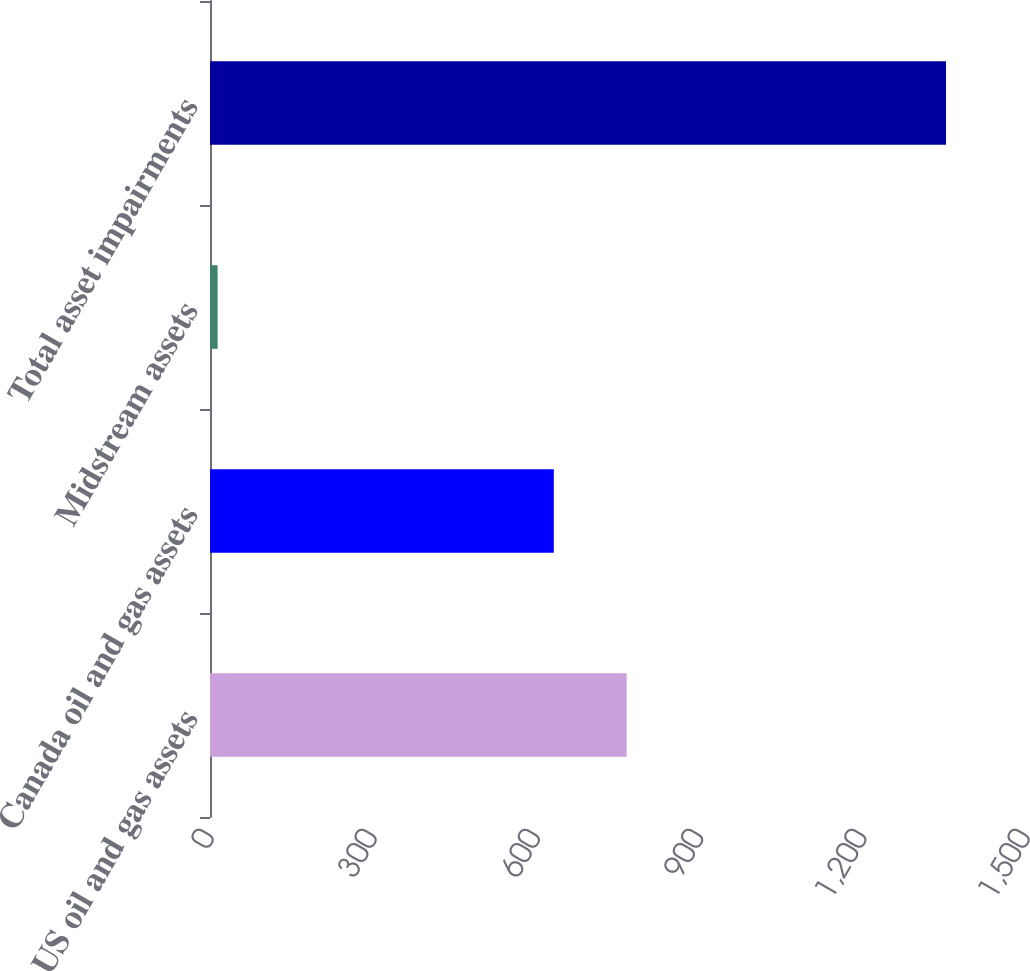Convert chart. <chart><loc_0><loc_0><loc_500><loc_500><bar_chart><fcel>US oil and gas assets<fcel>Canada oil and gas assets<fcel>Midstream assets<fcel>Total asset impairments<nl><fcel>765.9<fcel>632<fcel>14<fcel>1353<nl></chart> 